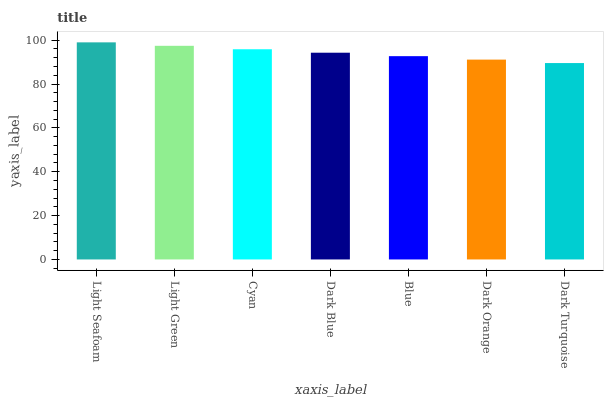Is Dark Turquoise the minimum?
Answer yes or no. Yes. Is Light Seafoam the maximum?
Answer yes or no. Yes. Is Light Green the minimum?
Answer yes or no. No. Is Light Green the maximum?
Answer yes or no. No. Is Light Seafoam greater than Light Green?
Answer yes or no. Yes. Is Light Green less than Light Seafoam?
Answer yes or no. Yes. Is Light Green greater than Light Seafoam?
Answer yes or no. No. Is Light Seafoam less than Light Green?
Answer yes or no. No. Is Dark Blue the high median?
Answer yes or no. Yes. Is Dark Blue the low median?
Answer yes or no. Yes. Is Dark Orange the high median?
Answer yes or no. No. Is Light Green the low median?
Answer yes or no. No. 